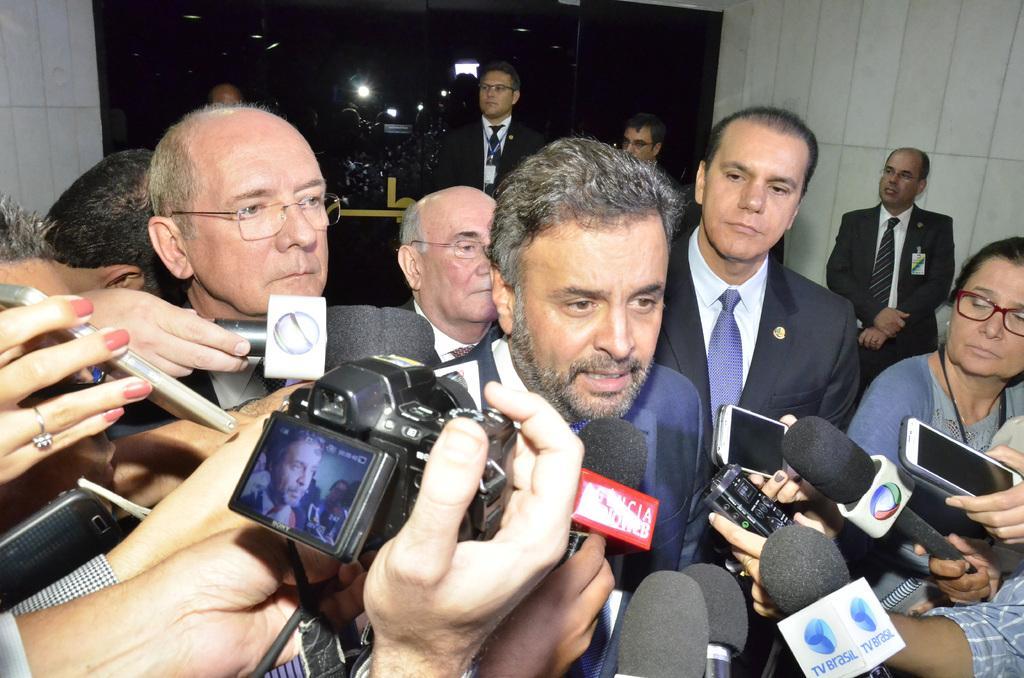In one or two sentences, can you explain what this image depicts? In this image I can see there are the group of persons standing and I can see there are the persons holding a mike and and a person holding a camera back side i can see a light visible. 